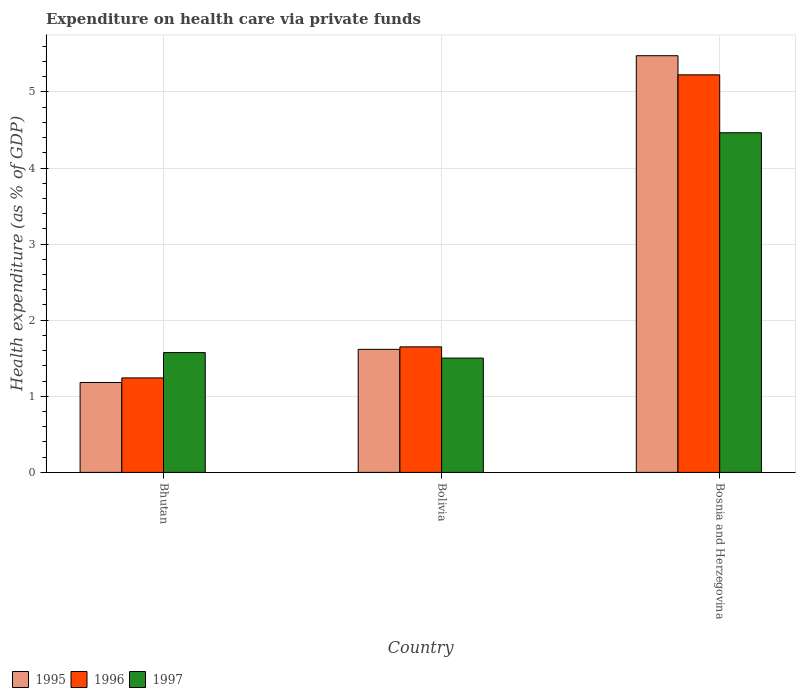Are the number of bars on each tick of the X-axis equal?
Offer a terse response. Yes. How many bars are there on the 2nd tick from the left?
Ensure brevity in your answer.  3. In how many cases, is the number of bars for a given country not equal to the number of legend labels?
Give a very brief answer. 0. What is the expenditure made on health care in 1996 in Bolivia?
Keep it short and to the point. 1.65. Across all countries, what is the maximum expenditure made on health care in 1997?
Provide a succinct answer. 4.46. Across all countries, what is the minimum expenditure made on health care in 1995?
Provide a short and direct response. 1.18. In which country was the expenditure made on health care in 1997 maximum?
Ensure brevity in your answer.  Bosnia and Herzegovina. In which country was the expenditure made on health care in 1996 minimum?
Your answer should be very brief. Bhutan. What is the total expenditure made on health care in 1997 in the graph?
Make the answer very short. 7.54. What is the difference between the expenditure made on health care in 1997 in Bhutan and that in Bolivia?
Make the answer very short. 0.07. What is the difference between the expenditure made on health care in 1996 in Bolivia and the expenditure made on health care in 1995 in Bhutan?
Keep it short and to the point. 0.47. What is the average expenditure made on health care in 1997 per country?
Offer a terse response. 2.51. What is the difference between the expenditure made on health care of/in 1997 and expenditure made on health care of/in 1996 in Bolivia?
Offer a very short reply. -0.15. In how many countries, is the expenditure made on health care in 1997 greater than 3.8 %?
Keep it short and to the point. 1. What is the ratio of the expenditure made on health care in 1997 in Bolivia to that in Bosnia and Herzegovina?
Provide a succinct answer. 0.34. Is the expenditure made on health care in 1995 in Bhutan less than that in Bolivia?
Ensure brevity in your answer.  Yes. Is the difference between the expenditure made on health care in 1997 in Bhutan and Bolivia greater than the difference between the expenditure made on health care in 1996 in Bhutan and Bolivia?
Provide a succinct answer. Yes. What is the difference between the highest and the second highest expenditure made on health care in 1996?
Your response must be concise. -3.57. What is the difference between the highest and the lowest expenditure made on health care in 1997?
Ensure brevity in your answer.  2.96. In how many countries, is the expenditure made on health care in 1997 greater than the average expenditure made on health care in 1997 taken over all countries?
Your response must be concise. 1. Is the sum of the expenditure made on health care in 1995 in Bhutan and Bolivia greater than the maximum expenditure made on health care in 1997 across all countries?
Offer a terse response. No. What does the 1st bar from the left in Bhutan represents?
Your response must be concise. 1995. Is it the case that in every country, the sum of the expenditure made on health care in 1996 and expenditure made on health care in 1995 is greater than the expenditure made on health care in 1997?
Give a very brief answer. Yes. How many bars are there?
Provide a short and direct response. 9. Are the values on the major ticks of Y-axis written in scientific E-notation?
Your answer should be compact. No. Does the graph contain grids?
Keep it short and to the point. Yes. How many legend labels are there?
Your answer should be compact. 3. What is the title of the graph?
Your response must be concise. Expenditure on health care via private funds. What is the label or title of the X-axis?
Your answer should be compact. Country. What is the label or title of the Y-axis?
Keep it short and to the point. Health expenditure (as % of GDP). What is the Health expenditure (as % of GDP) in 1995 in Bhutan?
Your answer should be compact. 1.18. What is the Health expenditure (as % of GDP) in 1996 in Bhutan?
Your response must be concise. 1.24. What is the Health expenditure (as % of GDP) in 1997 in Bhutan?
Provide a succinct answer. 1.57. What is the Health expenditure (as % of GDP) of 1995 in Bolivia?
Your answer should be compact. 1.62. What is the Health expenditure (as % of GDP) in 1996 in Bolivia?
Give a very brief answer. 1.65. What is the Health expenditure (as % of GDP) in 1997 in Bolivia?
Your answer should be compact. 1.5. What is the Health expenditure (as % of GDP) of 1995 in Bosnia and Herzegovina?
Give a very brief answer. 5.48. What is the Health expenditure (as % of GDP) of 1996 in Bosnia and Herzegovina?
Offer a terse response. 5.22. What is the Health expenditure (as % of GDP) in 1997 in Bosnia and Herzegovina?
Provide a succinct answer. 4.46. Across all countries, what is the maximum Health expenditure (as % of GDP) in 1995?
Provide a short and direct response. 5.48. Across all countries, what is the maximum Health expenditure (as % of GDP) of 1996?
Give a very brief answer. 5.22. Across all countries, what is the maximum Health expenditure (as % of GDP) in 1997?
Offer a terse response. 4.46. Across all countries, what is the minimum Health expenditure (as % of GDP) in 1995?
Give a very brief answer. 1.18. Across all countries, what is the minimum Health expenditure (as % of GDP) of 1996?
Your answer should be very brief. 1.24. Across all countries, what is the minimum Health expenditure (as % of GDP) in 1997?
Your answer should be very brief. 1.5. What is the total Health expenditure (as % of GDP) of 1995 in the graph?
Your response must be concise. 8.28. What is the total Health expenditure (as % of GDP) of 1996 in the graph?
Provide a short and direct response. 8.12. What is the total Health expenditure (as % of GDP) in 1997 in the graph?
Offer a very short reply. 7.54. What is the difference between the Health expenditure (as % of GDP) in 1995 in Bhutan and that in Bolivia?
Provide a succinct answer. -0.44. What is the difference between the Health expenditure (as % of GDP) in 1996 in Bhutan and that in Bolivia?
Keep it short and to the point. -0.41. What is the difference between the Health expenditure (as % of GDP) of 1997 in Bhutan and that in Bolivia?
Offer a terse response. 0.07. What is the difference between the Health expenditure (as % of GDP) of 1995 in Bhutan and that in Bosnia and Herzegovina?
Your answer should be very brief. -4.29. What is the difference between the Health expenditure (as % of GDP) of 1996 in Bhutan and that in Bosnia and Herzegovina?
Make the answer very short. -3.98. What is the difference between the Health expenditure (as % of GDP) in 1997 in Bhutan and that in Bosnia and Herzegovina?
Your response must be concise. -2.89. What is the difference between the Health expenditure (as % of GDP) in 1995 in Bolivia and that in Bosnia and Herzegovina?
Make the answer very short. -3.86. What is the difference between the Health expenditure (as % of GDP) in 1996 in Bolivia and that in Bosnia and Herzegovina?
Provide a short and direct response. -3.57. What is the difference between the Health expenditure (as % of GDP) of 1997 in Bolivia and that in Bosnia and Herzegovina?
Make the answer very short. -2.96. What is the difference between the Health expenditure (as % of GDP) of 1995 in Bhutan and the Health expenditure (as % of GDP) of 1996 in Bolivia?
Provide a succinct answer. -0.47. What is the difference between the Health expenditure (as % of GDP) of 1995 in Bhutan and the Health expenditure (as % of GDP) of 1997 in Bolivia?
Ensure brevity in your answer.  -0.32. What is the difference between the Health expenditure (as % of GDP) of 1996 in Bhutan and the Health expenditure (as % of GDP) of 1997 in Bolivia?
Provide a succinct answer. -0.26. What is the difference between the Health expenditure (as % of GDP) of 1995 in Bhutan and the Health expenditure (as % of GDP) of 1996 in Bosnia and Herzegovina?
Make the answer very short. -4.04. What is the difference between the Health expenditure (as % of GDP) in 1995 in Bhutan and the Health expenditure (as % of GDP) in 1997 in Bosnia and Herzegovina?
Your response must be concise. -3.28. What is the difference between the Health expenditure (as % of GDP) of 1996 in Bhutan and the Health expenditure (as % of GDP) of 1997 in Bosnia and Herzegovina?
Provide a succinct answer. -3.22. What is the difference between the Health expenditure (as % of GDP) of 1995 in Bolivia and the Health expenditure (as % of GDP) of 1996 in Bosnia and Herzegovina?
Keep it short and to the point. -3.61. What is the difference between the Health expenditure (as % of GDP) of 1995 in Bolivia and the Health expenditure (as % of GDP) of 1997 in Bosnia and Herzegovina?
Your answer should be compact. -2.85. What is the difference between the Health expenditure (as % of GDP) of 1996 in Bolivia and the Health expenditure (as % of GDP) of 1997 in Bosnia and Herzegovina?
Provide a short and direct response. -2.81. What is the average Health expenditure (as % of GDP) in 1995 per country?
Provide a succinct answer. 2.76. What is the average Health expenditure (as % of GDP) in 1996 per country?
Your answer should be very brief. 2.71. What is the average Health expenditure (as % of GDP) of 1997 per country?
Offer a terse response. 2.51. What is the difference between the Health expenditure (as % of GDP) of 1995 and Health expenditure (as % of GDP) of 1996 in Bhutan?
Offer a very short reply. -0.06. What is the difference between the Health expenditure (as % of GDP) in 1995 and Health expenditure (as % of GDP) in 1997 in Bhutan?
Give a very brief answer. -0.39. What is the difference between the Health expenditure (as % of GDP) in 1996 and Health expenditure (as % of GDP) in 1997 in Bhutan?
Your answer should be very brief. -0.33. What is the difference between the Health expenditure (as % of GDP) in 1995 and Health expenditure (as % of GDP) in 1996 in Bolivia?
Ensure brevity in your answer.  -0.03. What is the difference between the Health expenditure (as % of GDP) in 1995 and Health expenditure (as % of GDP) in 1997 in Bolivia?
Your response must be concise. 0.11. What is the difference between the Health expenditure (as % of GDP) in 1996 and Health expenditure (as % of GDP) in 1997 in Bolivia?
Ensure brevity in your answer.  0.15. What is the difference between the Health expenditure (as % of GDP) in 1995 and Health expenditure (as % of GDP) in 1996 in Bosnia and Herzegovina?
Your answer should be compact. 0.25. What is the difference between the Health expenditure (as % of GDP) in 1995 and Health expenditure (as % of GDP) in 1997 in Bosnia and Herzegovina?
Offer a very short reply. 1.01. What is the difference between the Health expenditure (as % of GDP) of 1996 and Health expenditure (as % of GDP) of 1997 in Bosnia and Herzegovina?
Offer a very short reply. 0.76. What is the ratio of the Health expenditure (as % of GDP) of 1995 in Bhutan to that in Bolivia?
Provide a short and direct response. 0.73. What is the ratio of the Health expenditure (as % of GDP) in 1996 in Bhutan to that in Bolivia?
Provide a short and direct response. 0.75. What is the ratio of the Health expenditure (as % of GDP) of 1997 in Bhutan to that in Bolivia?
Give a very brief answer. 1.05. What is the ratio of the Health expenditure (as % of GDP) of 1995 in Bhutan to that in Bosnia and Herzegovina?
Your answer should be compact. 0.22. What is the ratio of the Health expenditure (as % of GDP) in 1996 in Bhutan to that in Bosnia and Herzegovina?
Your answer should be compact. 0.24. What is the ratio of the Health expenditure (as % of GDP) in 1997 in Bhutan to that in Bosnia and Herzegovina?
Provide a short and direct response. 0.35. What is the ratio of the Health expenditure (as % of GDP) in 1995 in Bolivia to that in Bosnia and Herzegovina?
Provide a succinct answer. 0.3. What is the ratio of the Health expenditure (as % of GDP) of 1996 in Bolivia to that in Bosnia and Herzegovina?
Keep it short and to the point. 0.32. What is the ratio of the Health expenditure (as % of GDP) in 1997 in Bolivia to that in Bosnia and Herzegovina?
Provide a short and direct response. 0.34. What is the difference between the highest and the second highest Health expenditure (as % of GDP) in 1995?
Keep it short and to the point. 3.86. What is the difference between the highest and the second highest Health expenditure (as % of GDP) of 1996?
Make the answer very short. 3.57. What is the difference between the highest and the second highest Health expenditure (as % of GDP) of 1997?
Offer a very short reply. 2.89. What is the difference between the highest and the lowest Health expenditure (as % of GDP) in 1995?
Your answer should be very brief. 4.29. What is the difference between the highest and the lowest Health expenditure (as % of GDP) of 1996?
Keep it short and to the point. 3.98. What is the difference between the highest and the lowest Health expenditure (as % of GDP) in 1997?
Ensure brevity in your answer.  2.96. 